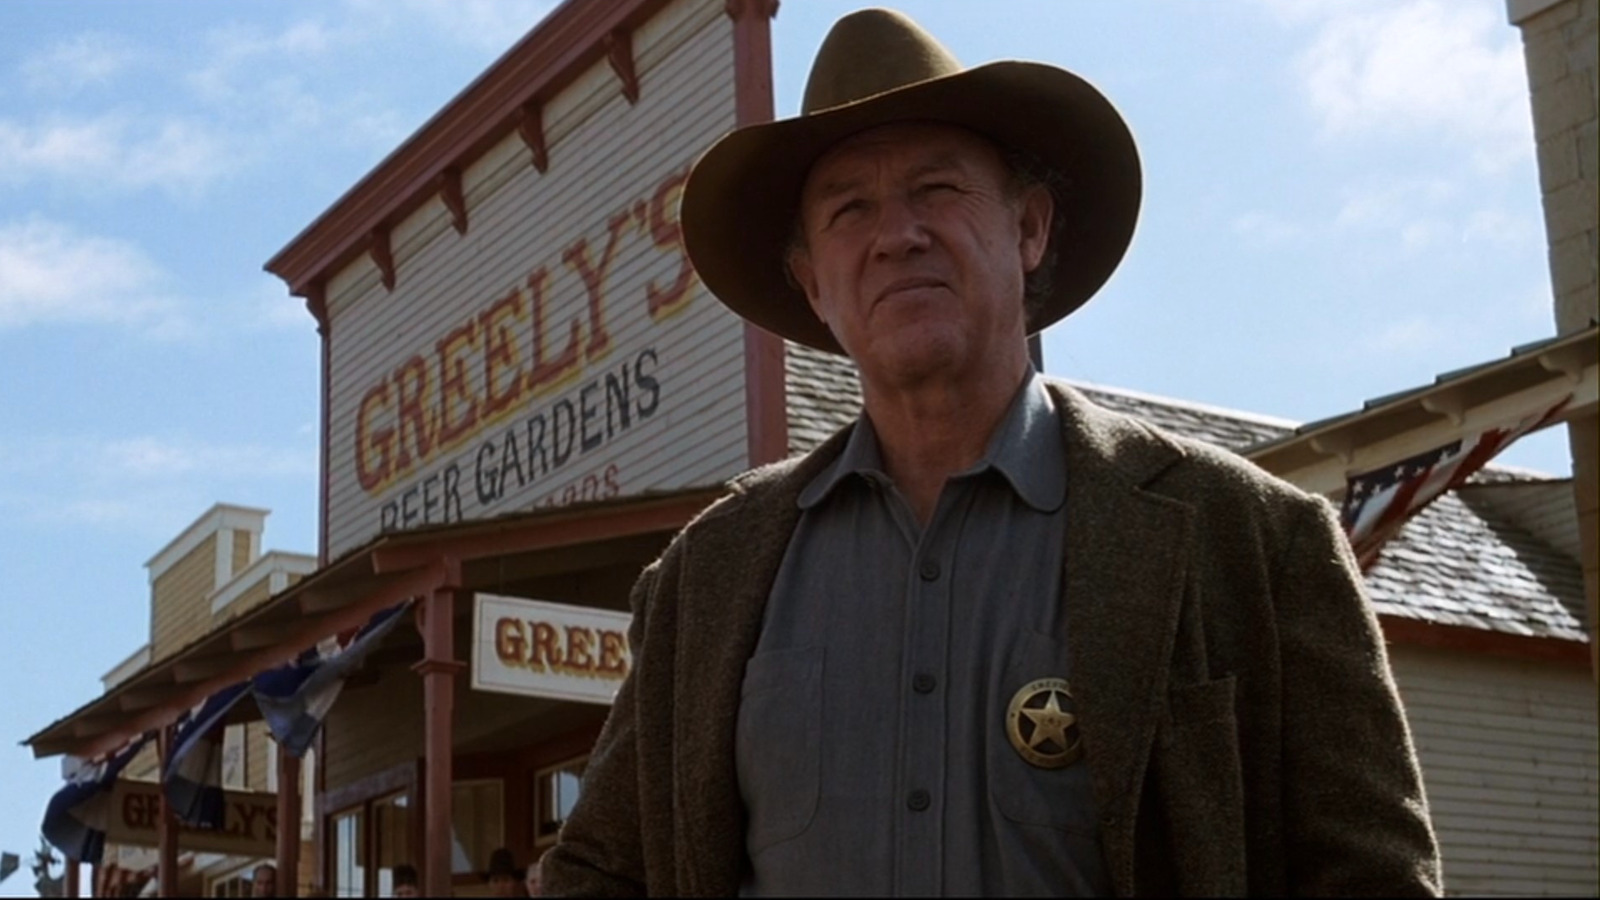What do you see happening in this image? The image features the actor Gene Hackman in a scene from the film 'The Quick and the Dead'. He stands in front of a saloon with a sign reading 'Greenly's Beer Gardens', portraying a serious character in a Western setting. Hackman is dressed in period attire suitable for the film's genre, reflecting the styles of the late 19th century with a broad-brimmed hat, and a jacket over a shirt. His expression and posture suggest a narrative of authority and readiness, setting the tone for a classic Western drama. 